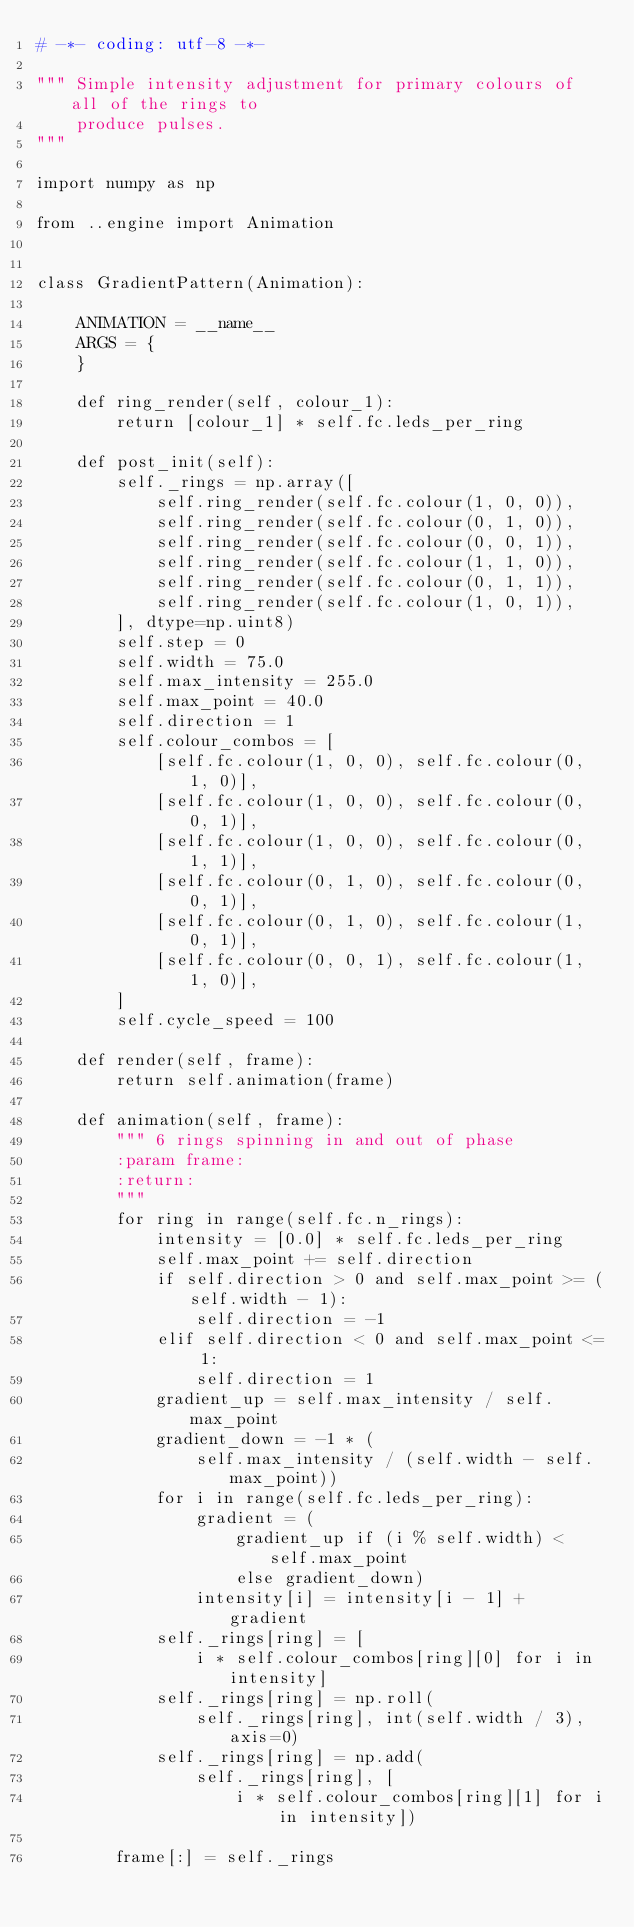Convert code to text. <code><loc_0><loc_0><loc_500><loc_500><_Python_># -*- coding: utf-8 -*-

""" Simple intensity adjustment for primary colours of all of the rings to
    produce pulses.
"""

import numpy as np

from ..engine import Animation


class GradientPattern(Animation):

    ANIMATION = __name__
    ARGS = {
    }

    def ring_render(self, colour_1):
        return [colour_1] * self.fc.leds_per_ring

    def post_init(self):
        self._rings = np.array([
            self.ring_render(self.fc.colour(1, 0, 0)),
            self.ring_render(self.fc.colour(0, 1, 0)),
            self.ring_render(self.fc.colour(0, 0, 1)),
            self.ring_render(self.fc.colour(1, 1, 0)),
            self.ring_render(self.fc.colour(0, 1, 1)),
            self.ring_render(self.fc.colour(1, 0, 1)),
        ], dtype=np.uint8)
        self.step = 0
        self.width = 75.0
        self.max_intensity = 255.0
        self.max_point = 40.0
        self.direction = 1
        self.colour_combos = [
            [self.fc.colour(1, 0, 0), self.fc.colour(0, 1, 0)],
            [self.fc.colour(1, 0, 0), self.fc.colour(0, 0, 1)],
            [self.fc.colour(1, 0, 0), self.fc.colour(0, 1, 1)],
            [self.fc.colour(0, 1, 0), self.fc.colour(0, 0, 1)],
            [self.fc.colour(0, 1, 0), self.fc.colour(1, 0, 1)],
            [self.fc.colour(0, 0, 1), self.fc.colour(1, 1, 0)],
        ]
        self.cycle_speed = 100

    def render(self, frame):
        return self.animation(frame)

    def animation(self, frame):
        """ 6 rings spinning in and out of phase
        :param frame:
        :return:
        """
        for ring in range(self.fc.n_rings):
            intensity = [0.0] * self.fc.leds_per_ring
            self.max_point += self.direction
            if self.direction > 0 and self.max_point >= (self.width - 1):
                self.direction = -1
            elif self.direction < 0 and self.max_point <= 1:
                self.direction = 1
            gradient_up = self.max_intensity / self.max_point
            gradient_down = -1 * (
                self.max_intensity / (self.width - self.max_point))
            for i in range(self.fc.leds_per_ring):
                gradient = (
                    gradient_up if (i % self.width) < self.max_point
                    else gradient_down)
                intensity[i] = intensity[i - 1] + gradient
            self._rings[ring] = [
                i * self.colour_combos[ring][0] for i in intensity]
            self._rings[ring] = np.roll(
                self._rings[ring], int(self.width / 3), axis=0)
            self._rings[ring] = np.add(
                self._rings[ring], [
                    i * self.colour_combos[ring][1] for i in intensity])

        frame[:] = self._rings
</code> 